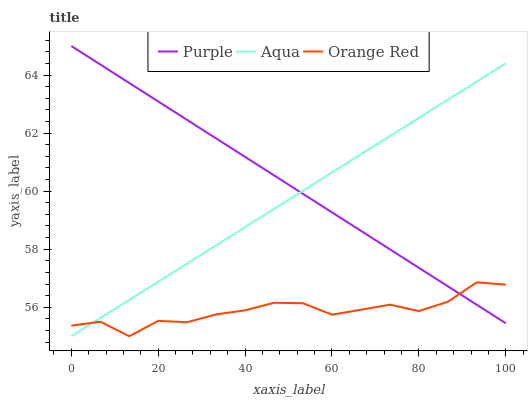Does Orange Red have the minimum area under the curve?
Answer yes or no. Yes. Does Purple have the maximum area under the curve?
Answer yes or no. Yes. Does Aqua have the minimum area under the curve?
Answer yes or no. No. Does Aqua have the maximum area under the curve?
Answer yes or no. No. Is Aqua the smoothest?
Answer yes or no. Yes. Is Orange Red the roughest?
Answer yes or no. Yes. Is Orange Red the smoothest?
Answer yes or no. No. Is Aqua the roughest?
Answer yes or no. No. Does Aqua have the lowest value?
Answer yes or no. Yes. Does Purple have the highest value?
Answer yes or no. Yes. Does Aqua have the highest value?
Answer yes or no. No. Does Purple intersect Aqua?
Answer yes or no. Yes. Is Purple less than Aqua?
Answer yes or no. No. Is Purple greater than Aqua?
Answer yes or no. No. 